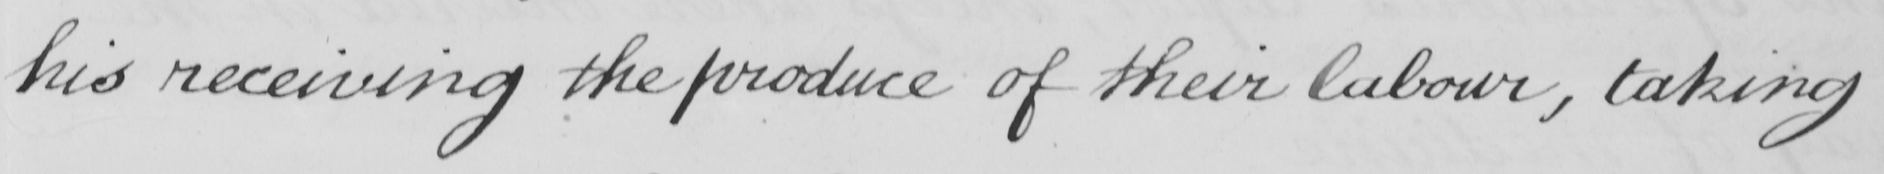Can you read and transcribe this handwriting? his receiving the produce of their labour , taking 